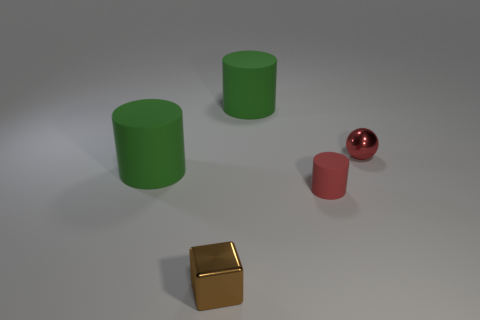Subtract all yellow cylinders. Subtract all gray balls. How many cylinders are left? 3 Add 1 metallic things. How many objects exist? 6 Subtract all spheres. How many objects are left? 4 Add 5 green objects. How many green objects exist? 7 Subtract 0 green spheres. How many objects are left? 5 Subtract all metal objects. Subtract all big cylinders. How many objects are left? 1 Add 3 small matte cylinders. How many small matte cylinders are left? 4 